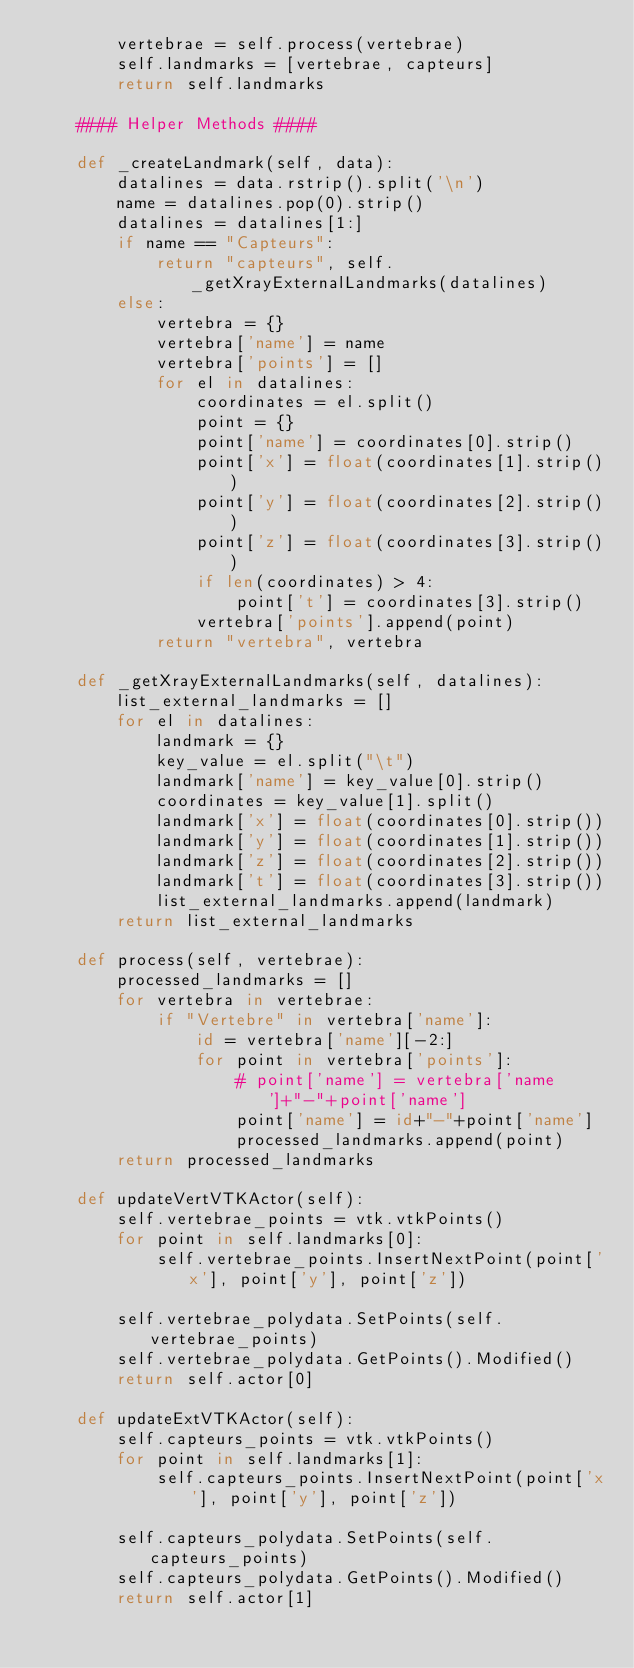<code> <loc_0><loc_0><loc_500><loc_500><_Python_>        vertebrae = self.process(vertebrae)
        self.landmarks = [vertebrae, capteurs]
        return self.landmarks

    #### Helper Methods ####

    def _createLandmark(self, data):
        datalines = data.rstrip().split('\n')
        name = datalines.pop(0).strip()
        datalines = datalines[1:]
        if name == "Capteurs":
            return "capteurs", self._getXrayExternalLandmarks(datalines)
        else:
            vertebra = {}
            vertebra['name'] = name
            vertebra['points'] = []
            for el in datalines:
                coordinates = el.split()
                point = {}
                point['name'] = coordinates[0].strip()
                point['x'] = float(coordinates[1].strip())
                point['y'] = float(coordinates[2].strip())
                point['z'] = float(coordinates[3].strip())
                if len(coordinates) > 4:
                    point['t'] = coordinates[3].strip()
                vertebra['points'].append(point)
            return "vertebra", vertebra

    def _getXrayExternalLandmarks(self, datalines):
        list_external_landmarks = []
        for el in datalines:
            landmark = {}
            key_value = el.split("\t")
            landmark['name'] = key_value[0].strip()
            coordinates = key_value[1].split()
            landmark['x'] = float(coordinates[0].strip())
            landmark['y'] = float(coordinates[1].strip())
            landmark['z'] = float(coordinates[2].strip())
            landmark['t'] = float(coordinates[3].strip())
            list_external_landmarks.append(landmark)
        return list_external_landmarks

    def process(self, vertebrae):
        processed_landmarks = []
        for vertebra in vertebrae:
            if "Vertebre" in vertebra['name']:
                id = vertebra['name'][-2:]
                for point in vertebra['points']:
                    # point['name'] = vertebra['name']+"-"+point['name']
                    point['name'] = id+"-"+point['name']
                    processed_landmarks.append(point)
        return processed_landmarks

    def updateVertVTKActor(self):
        self.vertebrae_points = vtk.vtkPoints()
        for point in self.landmarks[0]:
            self.vertebrae_points.InsertNextPoint(point['x'], point['y'], point['z'])

        self.vertebrae_polydata.SetPoints(self.vertebrae_points)
        self.vertebrae_polydata.GetPoints().Modified()
        return self.actor[0]

    def updateExtVTKActor(self):
        self.capteurs_points = vtk.vtkPoints()
        for point in self.landmarks[1]:
            self.capteurs_points.InsertNextPoint(point['x'], point['y'], point['z'])

        self.capteurs_polydata.SetPoints(self.capteurs_points)
        self.capteurs_polydata.GetPoints().Modified()
        return self.actor[1]</code> 